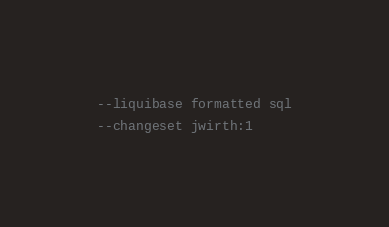<code> <loc_0><loc_0><loc_500><loc_500><_SQL_>--liquibase formatted sql

--changeset jwirth:1</code> 